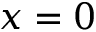Convert formula to latex. <formula><loc_0><loc_0><loc_500><loc_500>x = 0</formula> 